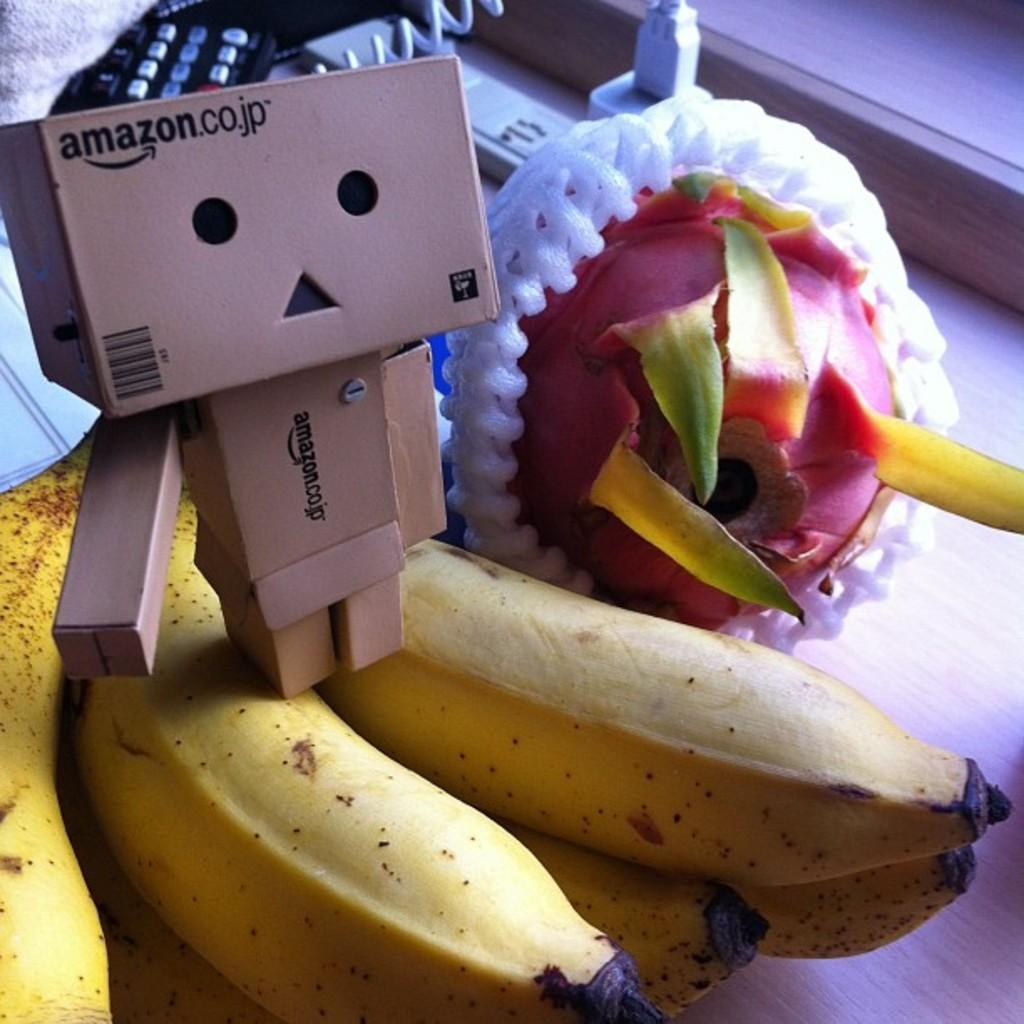What type of objects are on the wooden surface in the image? There are fruits on a wooden surface in the image. What other type of object can be seen in the image? There is a toy in the image. What items are related to electronic devices in the image? There are remotes in the image. What kind of connection is visible in the image? There is a cable in the image. Can you describe any other objects present in the image? There are other objects present in the image, but their specific details are not mentioned in the provided facts. Where is the pocket located in the image? There is no pocket present in the image. What type of bottle can be seen in the image? There is no bottle present in the image. 